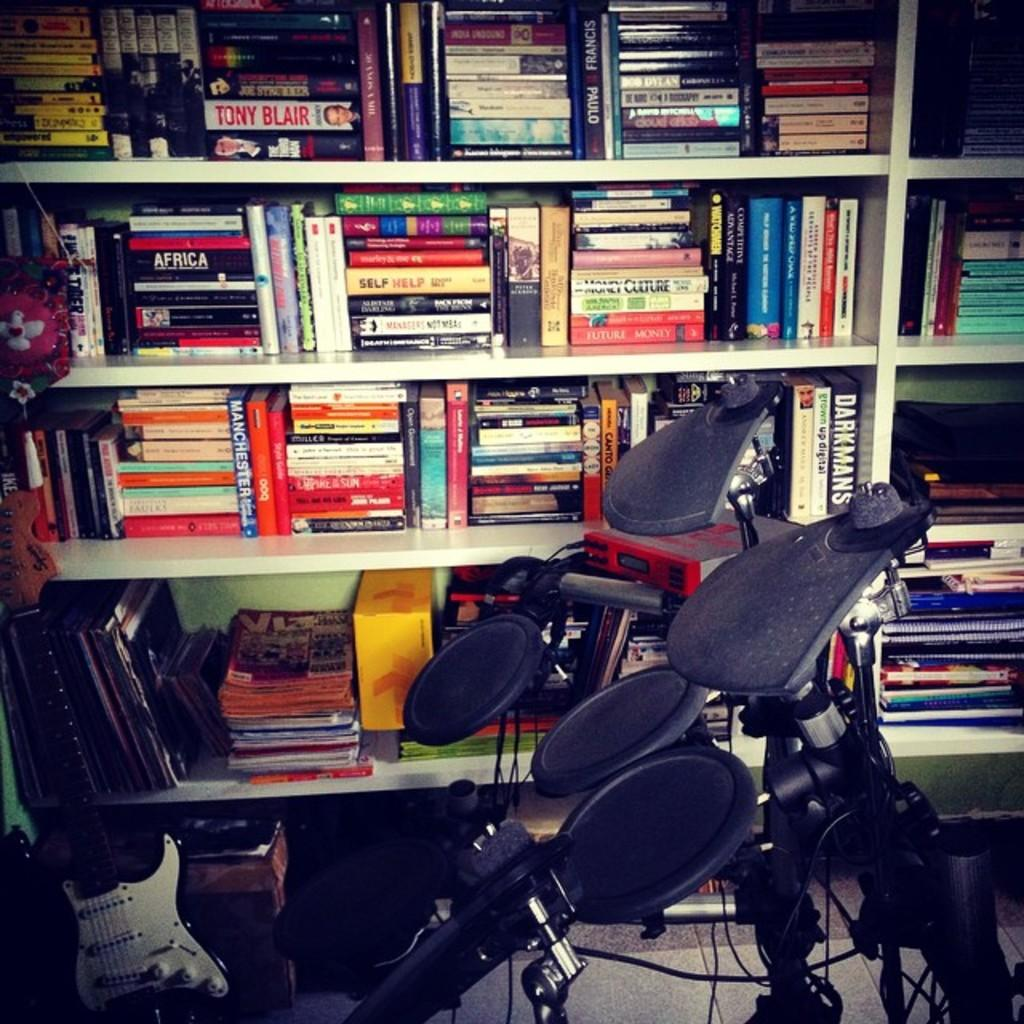<image>
Write a terse but informative summary of the picture. many books, one with the word future on it 